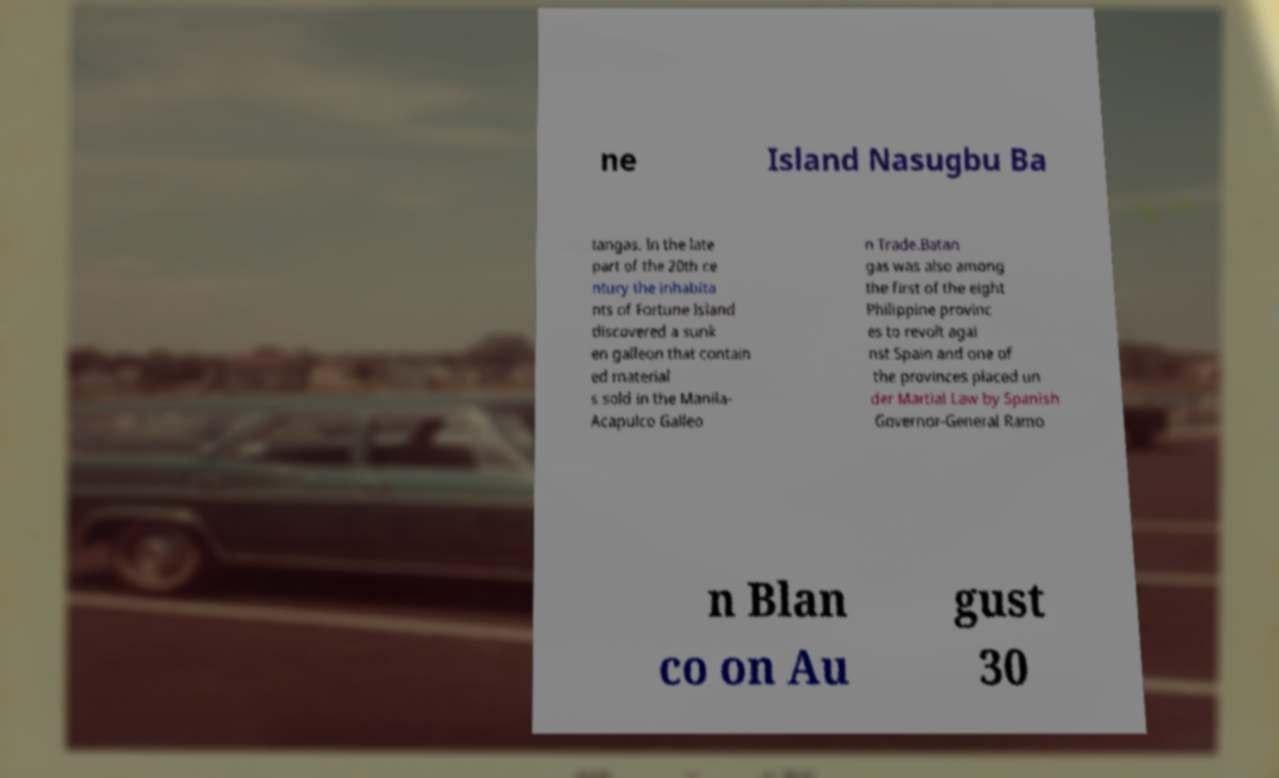I need the written content from this picture converted into text. Can you do that? ne Island Nasugbu Ba tangas. In the late part of the 20th ce ntury the inhabita nts of Fortune Island discovered a sunk en galleon that contain ed material s sold in the Manila- Acapulco Galleo n Trade.Batan gas was also among the first of the eight Philippine provinc es to revolt agai nst Spain and one of the provinces placed un der Martial Law by Spanish Governor-General Ramo n Blan co on Au gust 30 